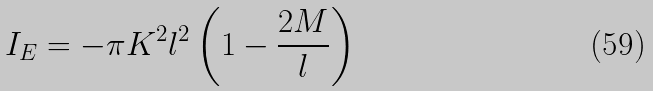<formula> <loc_0><loc_0><loc_500><loc_500>I _ { E } = - \pi K ^ { 2 } l ^ { 2 } \left ( 1 - \frac { 2 M } { l } \right )</formula> 